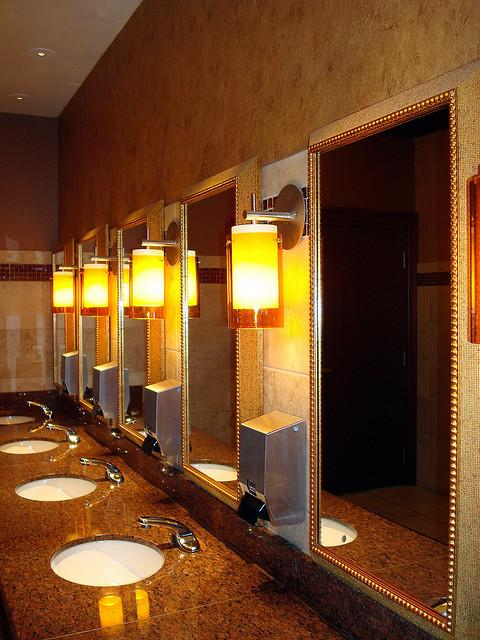What are the metal boxes on the wall used for?

Choices:
A) towels
B) hot water
C) soap dispenser
D) dry hands soap dispenser 